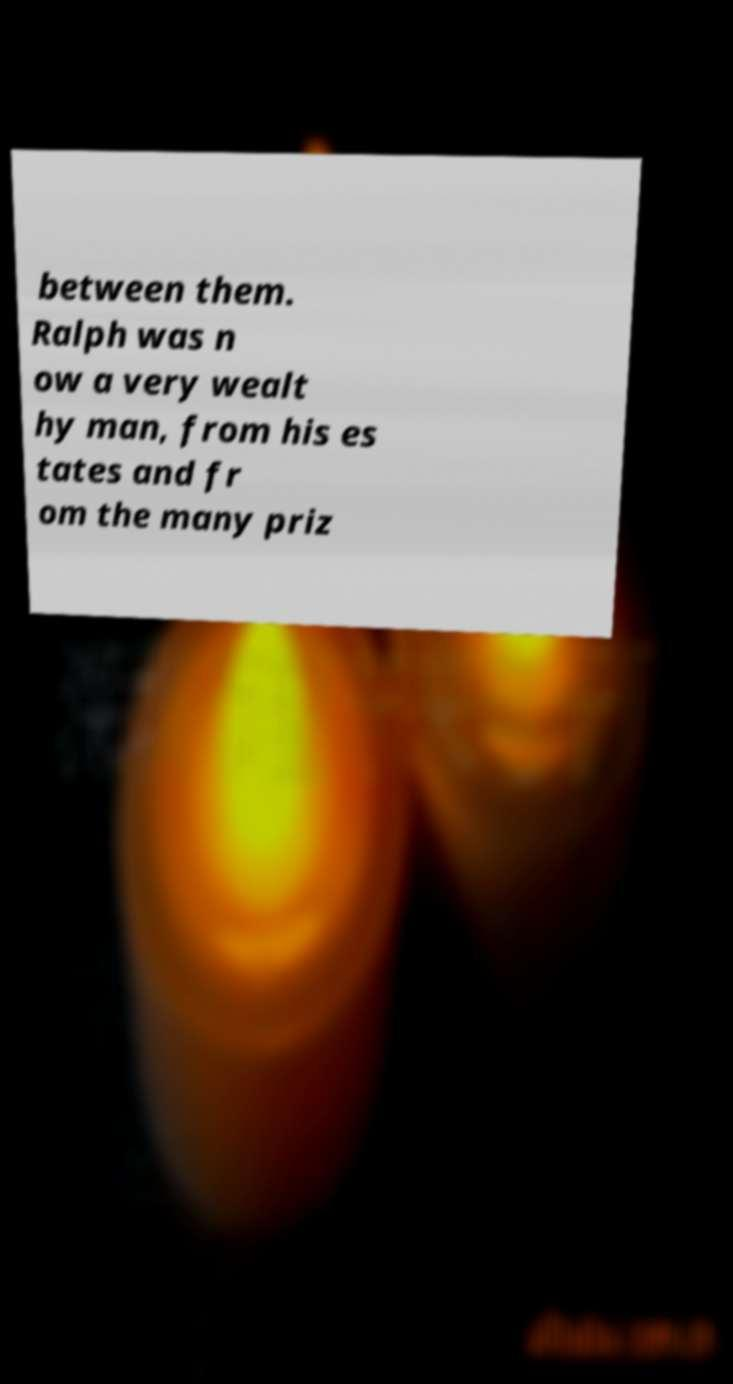Please read and relay the text visible in this image. What does it say? between them. Ralph was n ow a very wealt hy man, from his es tates and fr om the many priz 